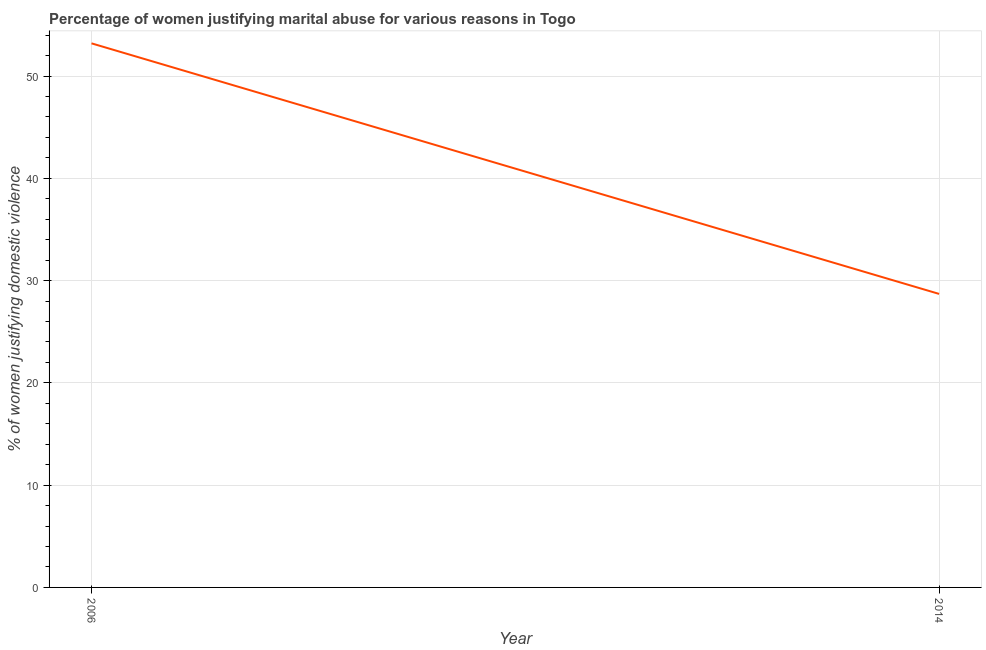What is the percentage of women justifying marital abuse in 2014?
Your answer should be compact. 28.7. Across all years, what is the maximum percentage of women justifying marital abuse?
Give a very brief answer. 53.2. Across all years, what is the minimum percentage of women justifying marital abuse?
Offer a very short reply. 28.7. In which year was the percentage of women justifying marital abuse maximum?
Offer a very short reply. 2006. What is the sum of the percentage of women justifying marital abuse?
Your answer should be compact. 81.9. What is the difference between the percentage of women justifying marital abuse in 2006 and 2014?
Your answer should be compact. 24.5. What is the average percentage of women justifying marital abuse per year?
Your answer should be compact. 40.95. What is the median percentage of women justifying marital abuse?
Your answer should be very brief. 40.95. In how many years, is the percentage of women justifying marital abuse greater than 34 %?
Your answer should be compact. 1. What is the ratio of the percentage of women justifying marital abuse in 2006 to that in 2014?
Provide a short and direct response. 1.85. Is the percentage of women justifying marital abuse in 2006 less than that in 2014?
Ensure brevity in your answer.  No. Does the percentage of women justifying marital abuse monotonically increase over the years?
Keep it short and to the point. No. Are the values on the major ticks of Y-axis written in scientific E-notation?
Give a very brief answer. No. Does the graph contain any zero values?
Your answer should be very brief. No. What is the title of the graph?
Your response must be concise. Percentage of women justifying marital abuse for various reasons in Togo. What is the label or title of the Y-axis?
Your answer should be very brief. % of women justifying domestic violence. What is the % of women justifying domestic violence in 2006?
Keep it short and to the point. 53.2. What is the % of women justifying domestic violence in 2014?
Your response must be concise. 28.7. What is the ratio of the % of women justifying domestic violence in 2006 to that in 2014?
Offer a very short reply. 1.85. 